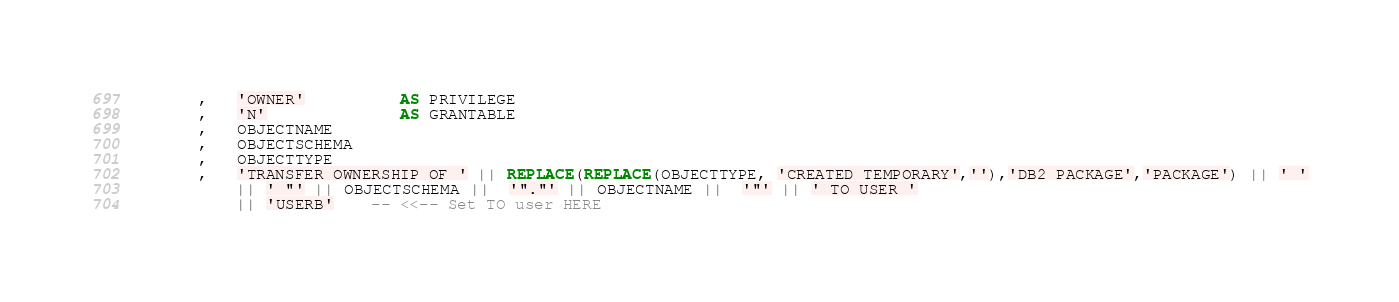<code> <loc_0><loc_0><loc_500><loc_500><_SQL_>        ,   'OWNER'          AS PRIVILEGE
        ,   'N'              AS GRANTABLE
        ,   OBJECTNAME
        ,   OBJECTSCHEMA
        ,   OBJECTTYPE
        ,   'TRANSFER OWNERSHIP OF ' || REPLACE(REPLACE(OBJECTTYPE, 'CREATED TEMPORARY',''),'DB2 PACKAGE','PACKAGE') || ' '
            || ' "' || OBJECTSCHEMA ||  '"."' || OBJECTNAME ||  '"' || ' TO USER '
            || 'USERB'    -- <<-- Set TO user HERE</code> 